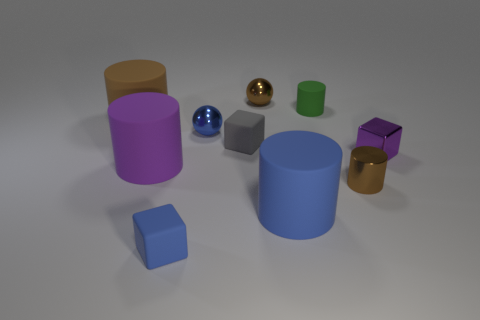There is a blue matte thing right of the tiny blue object that is behind the small gray object; what is its shape?
Give a very brief answer. Cylinder. There is a gray object; is its shape the same as the brown metal object that is behind the small gray rubber cube?
Your answer should be very brief. No. What is the color of the shiny cylinder that is the same size as the brown metal ball?
Provide a short and direct response. Brown. Are there fewer purple cylinders on the right side of the blue metal ball than small metallic blocks that are behind the green cylinder?
Make the answer very short. No. What is the shape of the brown metallic object that is behind the large rubber thing that is behind the metal object left of the small brown metal ball?
Your answer should be compact. Sphere. There is a shiny ball that is behind the tiny blue metallic object; is its color the same as the metallic ball that is in front of the green thing?
Your answer should be compact. No. The large matte object that is the same color as the small metallic block is what shape?
Provide a succinct answer. Cylinder. What number of shiny objects are brown balls or small green cylinders?
Your answer should be compact. 1. What color is the tiny cylinder behind the brown metal thing that is in front of the matte block right of the small blue block?
Offer a very short reply. Green. There is another small metal object that is the same shape as the green object; what is its color?
Give a very brief answer. Brown. 